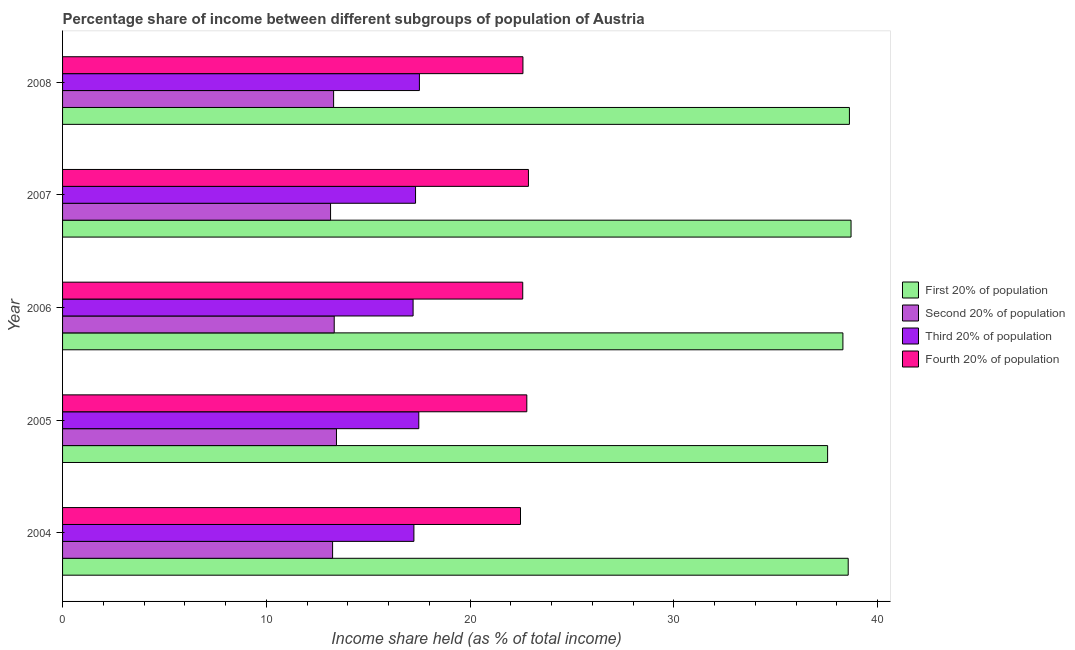How many different coloured bars are there?
Offer a very short reply. 4. How many groups of bars are there?
Make the answer very short. 5. Are the number of bars per tick equal to the number of legend labels?
Ensure brevity in your answer.  Yes. Are the number of bars on each tick of the Y-axis equal?
Provide a succinct answer. Yes. What is the share of the income held by first 20% of the population in 2006?
Provide a succinct answer. 38.29. Across all years, what is the maximum share of the income held by first 20% of the population?
Offer a very short reply. 38.69. Across all years, what is the minimum share of the income held by second 20% of the population?
Provide a succinct answer. 13.15. In which year was the share of the income held by third 20% of the population maximum?
Provide a succinct answer. 2008. What is the total share of the income held by fourth 20% of the population in the graph?
Offer a very short reply. 113.28. What is the difference between the share of the income held by third 20% of the population in 2005 and that in 2008?
Your answer should be compact. -0.03. What is the difference between the share of the income held by first 20% of the population in 2008 and the share of the income held by second 20% of the population in 2007?
Keep it short and to the point. 25.46. What is the average share of the income held by third 20% of the population per year?
Your response must be concise. 17.35. In the year 2006, what is the difference between the share of the income held by fourth 20% of the population and share of the income held by first 20% of the population?
Ensure brevity in your answer.  -15.71. In how many years, is the share of the income held by fourth 20% of the population greater than 28 %?
Ensure brevity in your answer.  0. What is the ratio of the share of the income held by third 20% of the population in 2005 to that in 2006?
Ensure brevity in your answer.  1.02. Is the difference between the share of the income held by fourth 20% of the population in 2005 and 2008 greater than the difference between the share of the income held by third 20% of the population in 2005 and 2008?
Make the answer very short. Yes. What is the difference between the highest and the second highest share of the income held by second 20% of the population?
Offer a terse response. 0.11. What is the difference between the highest and the lowest share of the income held by second 20% of the population?
Provide a short and direct response. 0.29. Is it the case that in every year, the sum of the share of the income held by first 20% of the population and share of the income held by third 20% of the population is greater than the sum of share of the income held by fourth 20% of the population and share of the income held by second 20% of the population?
Offer a very short reply. Yes. What does the 1st bar from the top in 2007 represents?
Provide a succinct answer. Fourth 20% of population. What does the 2nd bar from the bottom in 2008 represents?
Offer a very short reply. Second 20% of population. Is it the case that in every year, the sum of the share of the income held by first 20% of the population and share of the income held by second 20% of the population is greater than the share of the income held by third 20% of the population?
Make the answer very short. Yes. How many years are there in the graph?
Offer a terse response. 5. Are the values on the major ticks of X-axis written in scientific E-notation?
Provide a succinct answer. No. Does the graph contain grids?
Your answer should be very brief. No. Where does the legend appear in the graph?
Give a very brief answer. Center right. What is the title of the graph?
Keep it short and to the point. Percentage share of income between different subgroups of population of Austria. Does "Energy" appear as one of the legend labels in the graph?
Provide a short and direct response. No. What is the label or title of the X-axis?
Offer a very short reply. Income share held (as % of total income). What is the label or title of the Y-axis?
Ensure brevity in your answer.  Year. What is the Income share held (as % of total income) in First 20% of population in 2004?
Your response must be concise. 38.55. What is the Income share held (as % of total income) in Second 20% of population in 2004?
Provide a short and direct response. 13.25. What is the Income share held (as % of total income) of Third 20% of population in 2004?
Your answer should be compact. 17.24. What is the Income share held (as % of total income) in Fourth 20% of population in 2004?
Your answer should be very brief. 22.47. What is the Income share held (as % of total income) in First 20% of population in 2005?
Your answer should be very brief. 37.54. What is the Income share held (as % of total income) in Second 20% of population in 2005?
Your answer should be very brief. 13.44. What is the Income share held (as % of total income) of Third 20% of population in 2005?
Make the answer very short. 17.48. What is the Income share held (as % of total income) in Fourth 20% of population in 2005?
Ensure brevity in your answer.  22.78. What is the Income share held (as % of total income) in First 20% of population in 2006?
Give a very brief answer. 38.29. What is the Income share held (as % of total income) of Second 20% of population in 2006?
Your answer should be compact. 13.33. What is the Income share held (as % of total income) of Fourth 20% of population in 2006?
Make the answer very short. 22.58. What is the Income share held (as % of total income) in First 20% of population in 2007?
Make the answer very short. 38.69. What is the Income share held (as % of total income) of Second 20% of population in 2007?
Give a very brief answer. 13.15. What is the Income share held (as % of total income) in Third 20% of population in 2007?
Offer a very short reply. 17.32. What is the Income share held (as % of total income) in Fourth 20% of population in 2007?
Offer a terse response. 22.86. What is the Income share held (as % of total income) of First 20% of population in 2008?
Your response must be concise. 38.61. What is the Income share held (as % of total income) of Third 20% of population in 2008?
Offer a terse response. 17.51. What is the Income share held (as % of total income) of Fourth 20% of population in 2008?
Offer a very short reply. 22.59. Across all years, what is the maximum Income share held (as % of total income) in First 20% of population?
Your response must be concise. 38.69. Across all years, what is the maximum Income share held (as % of total income) in Second 20% of population?
Offer a terse response. 13.44. Across all years, what is the maximum Income share held (as % of total income) in Third 20% of population?
Your answer should be compact. 17.51. Across all years, what is the maximum Income share held (as % of total income) in Fourth 20% of population?
Keep it short and to the point. 22.86. Across all years, what is the minimum Income share held (as % of total income) of First 20% of population?
Provide a short and direct response. 37.54. Across all years, what is the minimum Income share held (as % of total income) of Second 20% of population?
Provide a short and direct response. 13.15. Across all years, what is the minimum Income share held (as % of total income) of Third 20% of population?
Provide a succinct answer. 17.2. Across all years, what is the minimum Income share held (as % of total income) in Fourth 20% of population?
Give a very brief answer. 22.47. What is the total Income share held (as % of total income) in First 20% of population in the graph?
Your answer should be very brief. 191.68. What is the total Income share held (as % of total income) in Second 20% of population in the graph?
Offer a very short reply. 66.47. What is the total Income share held (as % of total income) of Third 20% of population in the graph?
Make the answer very short. 86.75. What is the total Income share held (as % of total income) of Fourth 20% of population in the graph?
Your answer should be compact. 113.28. What is the difference between the Income share held (as % of total income) of First 20% of population in 2004 and that in 2005?
Your answer should be compact. 1.01. What is the difference between the Income share held (as % of total income) of Second 20% of population in 2004 and that in 2005?
Make the answer very short. -0.19. What is the difference between the Income share held (as % of total income) in Third 20% of population in 2004 and that in 2005?
Provide a succinct answer. -0.24. What is the difference between the Income share held (as % of total income) in Fourth 20% of population in 2004 and that in 2005?
Your answer should be very brief. -0.31. What is the difference between the Income share held (as % of total income) of First 20% of population in 2004 and that in 2006?
Make the answer very short. 0.26. What is the difference between the Income share held (as % of total income) of Second 20% of population in 2004 and that in 2006?
Ensure brevity in your answer.  -0.08. What is the difference between the Income share held (as % of total income) in Fourth 20% of population in 2004 and that in 2006?
Your answer should be compact. -0.11. What is the difference between the Income share held (as % of total income) of First 20% of population in 2004 and that in 2007?
Offer a terse response. -0.14. What is the difference between the Income share held (as % of total income) in Second 20% of population in 2004 and that in 2007?
Keep it short and to the point. 0.1. What is the difference between the Income share held (as % of total income) of Third 20% of population in 2004 and that in 2007?
Offer a terse response. -0.08. What is the difference between the Income share held (as % of total income) of Fourth 20% of population in 2004 and that in 2007?
Offer a very short reply. -0.39. What is the difference between the Income share held (as % of total income) of First 20% of population in 2004 and that in 2008?
Give a very brief answer. -0.06. What is the difference between the Income share held (as % of total income) in Third 20% of population in 2004 and that in 2008?
Provide a short and direct response. -0.27. What is the difference between the Income share held (as % of total income) in Fourth 20% of population in 2004 and that in 2008?
Offer a terse response. -0.12. What is the difference between the Income share held (as % of total income) in First 20% of population in 2005 and that in 2006?
Provide a short and direct response. -0.75. What is the difference between the Income share held (as % of total income) of Second 20% of population in 2005 and that in 2006?
Ensure brevity in your answer.  0.11. What is the difference between the Income share held (as % of total income) of Third 20% of population in 2005 and that in 2006?
Keep it short and to the point. 0.28. What is the difference between the Income share held (as % of total income) of Fourth 20% of population in 2005 and that in 2006?
Ensure brevity in your answer.  0.2. What is the difference between the Income share held (as % of total income) of First 20% of population in 2005 and that in 2007?
Ensure brevity in your answer.  -1.15. What is the difference between the Income share held (as % of total income) of Second 20% of population in 2005 and that in 2007?
Give a very brief answer. 0.29. What is the difference between the Income share held (as % of total income) of Third 20% of population in 2005 and that in 2007?
Keep it short and to the point. 0.16. What is the difference between the Income share held (as % of total income) of Fourth 20% of population in 2005 and that in 2007?
Provide a short and direct response. -0.08. What is the difference between the Income share held (as % of total income) in First 20% of population in 2005 and that in 2008?
Make the answer very short. -1.07. What is the difference between the Income share held (as % of total income) of Second 20% of population in 2005 and that in 2008?
Ensure brevity in your answer.  0.14. What is the difference between the Income share held (as % of total income) in Third 20% of population in 2005 and that in 2008?
Your response must be concise. -0.03. What is the difference between the Income share held (as % of total income) in Fourth 20% of population in 2005 and that in 2008?
Your response must be concise. 0.19. What is the difference between the Income share held (as % of total income) of First 20% of population in 2006 and that in 2007?
Your answer should be very brief. -0.4. What is the difference between the Income share held (as % of total income) of Second 20% of population in 2006 and that in 2007?
Your answer should be compact. 0.18. What is the difference between the Income share held (as % of total income) of Third 20% of population in 2006 and that in 2007?
Offer a very short reply. -0.12. What is the difference between the Income share held (as % of total income) in Fourth 20% of population in 2006 and that in 2007?
Keep it short and to the point. -0.28. What is the difference between the Income share held (as % of total income) in First 20% of population in 2006 and that in 2008?
Offer a very short reply. -0.32. What is the difference between the Income share held (as % of total income) in Third 20% of population in 2006 and that in 2008?
Give a very brief answer. -0.31. What is the difference between the Income share held (as % of total income) in Fourth 20% of population in 2006 and that in 2008?
Your response must be concise. -0.01. What is the difference between the Income share held (as % of total income) in Third 20% of population in 2007 and that in 2008?
Give a very brief answer. -0.19. What is the difference between the Income share held (as % of total income) in Fourth 20% of population in 2007 and that in 2008?
Keep it short and to the point. 0.27. What is the difference between the Income share held (as % of total income) of First 20% of population in 2004 and the Income share held (as % of total income) of Second 20% of population in 2005?
Provide a short and direct response. 25.11. What is the difference between the Income share held (as % of total income) in First 20% of population in 2004 and the Income share held (as % of total income) in Third 20% of population in 2005?
Provide a succinct answer. 21.07. What is the difference between the Income share held (as % of total income) in First 20% of population in 2004 and the Income share held (as % of total income) in Fourth 20% of population in 2005?
Keep it short and to the point. 15.77. What is the difference between the Income share held (as % of total income) in Second 20% of population in 2004 and the Income share held (as % of total income) in Third 20% of population in 2005?
Give a very brief answer. -4.23. What is the difference between the Income share held (as % of total income) in Second 20% of population in 2004 and the Income share held (as % of total income) in Fourth 20% of population in 2005?
Your answer should be compact. -9.53. What is the difference between the Income share held (as % of total income) of Third 20% of population in 2004 and the Income share held (as % of total income) of Fourth 20% of population in 2005?
Make the answer very short. -5.54. What is the difference between the Income share held (as % of total income) in First 20% of population in 2004 and the Income share held (as % of total income) in Second 20% of population in 2006?
Ensure brevity in your answer.  25.22. What is the difference between the Income share held (as % of total income) in First 20% of population in 2004 and the Income share held (as % of total income) in Third 20% of population in 2006?
Your answer should be compact. 21.35. What is the difference between the Income share held (as % of total income) in First 20% of population in 2004 and the Income share held (as % of total income) in Fourth 20% of population in 2006?
Your response must be concise. 15.97. What is the difference between the Income share held (as % of total income) in Second 20% of population in 2004 and the Income share held (as % of total income) in Third 20% of population in 2006?
Provide a short and direct response. -3.95. What is the difference between the Income share held (as % of total income) of Second 20% of population in 2004 and the Income share held (as % of total income) of Fourth 20% of population in 2006?
Offer a very short reply. -9.33. What is the difference between the Income share held (as % of total income) in Third 20% of population in 2004 and the Income share held (as % of total income) in Fourth 20% of population in 2006?
Offer a terse response. -5.34. What is the difference between the Income share held (as % of total income) in First 20% of population in 2004 and the Income share held (as % of total income) in Second 20% of population in 2007?
Your response must be concise. 25.4. What is the difference between the Income share held (as % of total income) of First 20% of population in 2004 and the Income share held (as % of total income) of Third 20% of population in 2007?
Your answer should be compact. 21.23. What is the difference between the Income share held (as % of total income) of First 20% of population in 2004 and the Income share held (as % of total income) of Fourth 20% of population in 2007?
Your answer should be compact. 15.69. What is the difference between the Income share held (as % of total income) in Second 20% of population in 2004 and the Income share held (as % of total income) in Third 20% of population in 2007?
Your answer should be compact. -4.07. What is the difference between the Income share held (as % of total income) of Second 20% of population in 2004 and the Income share held (as % of total income) of Fourth 20% of population in 2007?
Ensure brevity in your answer.  -9.61. What is the difference between the Income share held (as % of total income) in Third 20% of population in 2004 and the Income share held (as % of total income) in Fourth 20% of population in 2007?
Offer a very short reply. -5.62. What is the difference between the Income share held (as % of total income) of First 20% of population in 2004 and the Income share held (as % of total income) of Second 20% of population in 2008?
Ensure brevity in your answer.  25.25. What is the difference between the Income share held (as % of total income) of First 20% of population in 2004 and the Income share held (as % of total income) of Third 20% of population in 2008?
Provide a succinct answer. 21.04. What is the difference between the Income share held (as % of total income) in First 20% of population in 2004 and the Income share held (as % of total income) in Fourth 20% of population in 2008?
Give a very brief answer. 15.96. What is the difference between the Income share held (as % of total income) of Second 20% of population in 2004 and the Income share held (as % of total income) of Third 20% of population in 2008?
Your answer should be very brief. -4.26. What is the difference between the Income share held (as % of total income) in Second 20% of population in 2004 and the Income share held (as % of total income) in Fourth 20% of population in 2008?
Give a very brief answer. -9.34. What is the difference between the Income share held (as % of total income) of Third 20% of population in 2004 and the Income share held (as % of total income) of Fourth 20% of population in 2008?
Offer a very short reply. -5.35. What is the difference between the Income share held (as % of total income) in First 20% of population in 2005 and the Income share held (as % of total income) in Second 20% of population in 2006?
Ensure brevity in your answer.  24.21. What is the difference between the Income share held (as % of total income) of First 20% of population in 2005 and the Income share held (as % of total income) of Third 20% of population in 2006?
Your answer should be very brief. 20.34. What is the difference between the Income share held (as % of total income) in First 20% of population in 2005 and the Income share held (as % of total income) in Fourth 20% of population in 2006?
Provide a short and direct response. 14.96. What is the difference between the Income share held (as % of total income) in Second 20% of population in 2005 and the Income share held (as % of total income) in Third 20% of population in 2006?
Keep it short and to the point. -3.76. What is the difference between the Income share held (as % of total income) in Second 20% of population in 2005 and the Income share held (as % of total income) in Fourth 20% of population in 2006?
Provide a succinct answer. -9.14. What is the difference between the Income share held (as % of total income) of Third 20% of population in 2005 and the Income share held (as % of total income) of Fourth 20% of population in 2006?
Offer a terse response. -5.1. What is the difference between the Income share held (as % of total income) of First 20% of population in 2005 and the Income share held (as % of total income) of Second 20% of population in 2007?
Make the answer very short. 24.39. What is the difference between the Income share held (as % of total income) in First 20% of population in 2005 and the Income share held (as % of total income) in Third 20% of population in 2007?
Your answer should be compact. 20.22. What is the difference between the Income share held (as % of total income) in First 20% of population in 2005 and the Income share held (as % of total income) in Fourth 20% of population in 2007?
Provide a succinct answer. 14.68. What is the difference between the Income share held (as % of total income) in Second 20% of population in 2005 and the Income share held (as % of total income) in Third 20% of population in 2007?
Offer a terse response. -3.88. What is the difference between the Income share held (as % of total income) of Second 20% of population in 2005 and the Income share held (as % of total income) of Fourth 20% of population in 2007?
Give a very brief answer. -9.42. What is the difference between the Income share held (as % of total income) of Third 20% of population in 2005 and the Income share held (as % of total income) of Fourth 20% of population in 2007?
Give a very brief answer. -5.38. What is the difference between the Income share held (as % of total income) of First 20% of population in 2005 and the Income share held (as % of total income) of Second 20% of population in 2008?
Offer a very short reply. 24.24. What is the difference between the Income share held (as % of total income) in First 20% of population in 2005 and the Income share held (as % of total income) in Third 20% of population in 2008?
Give a very brief answer. 20.03. What is the difference between the Income share held (as % of total income) of First 20% of population in 2005 and the Income share held (as % of total income) of Fourth 20% of population in 2008?
Offer a very short reply. 14.95. What is the difference between the Income share held (as % of total income) in Second 20% of population in 2005 and the Income share held (as % of total income) in Third 20% of population in 2008?
Make the answer very short. -4.07. What is the difference between the Income share held (as % of total income) in Second 20% of population in 2005 and the Income share held (as % of total income) in Fourth 20% of population in 2008?
Provide a succinct answer. -9.15. What is the difference between the Income share held (as % of total income) in Third 20% of population in 2005 and the Income share held (as % of total income) in Fourth 20% of population in 2008?
Provide a short and direct response. -5.11. What is the difference between the Income share held (as % of total income) in First 20% of population in 2006 and the Income share held (as % of total income) in Second 20% of population in 2007?
Your answer should be compact. 25.14. What is the difference between the Income share held (as % of total income) of First 20% of population in 2006 and the Income share held (as % of total income) of Third 20% of population in 2007?
Your response must be concise. 20.97. What is the difference between the Income share held (as % of total income) in First 20% of population in 2006 and the Income share held (as % of total income) in Fourth 20% of population in 2007?
Your answer should be compact. 15.43. What is the difference between the Income share held (as % of total income) in Second 20% of population in 2006 and the Income share held (as % of total income) in Third 20% of population in 2007?
Provide a succinct answer. -3.99. What is the difference between the Income share held (as % of total income) in Second 20% of population in 2006 and the Income share held (as % of total income) in Fourth 20% of population in 2007?
Keep it short and to the point. -9.53. What is the difference between the Income share held (as % of total income) in Third 20% of population in 2006 and the Income share held (as % of total income) in Fourth 20% of population in 2007?
Your answer should be very brief. -5.66. What is the difference between the Income share held (as % of total income) of First 20% of population in 2006 and the Income share held (as % of total income) of Second 20% of population in 2008?
Your answer should be compact. 24.99. What is the difference between the Income share held (as % of total income) in First 20% of population in 2006 and the Income share held (as % of total income) in Third 20% of population in 2008?
Your answer should be compact. 20.78. What is the difference between the Income share held (as % of total income) in First 20% of population in 2006 and the Income share held (as % of total income) in Fourth 20% of population in 2008?
Make the answer very short. 15.7. What is the difference between the Income share held (as % of total income) of Second 20% of population in 2006 and the Income share held (as % of total income) of Third 20% of population in 2008?
Your answer should be very brief. -4.18. What is the difference between the Income share held (as % of total income) in Second 20% of population in 2006 and the Income share held (as % of total income) in Fourth 20% of population in 2008?
Your answer should be very brief. -9.26. What is the difference between the Income share held (as % of total income) in Third 20% of population in 2006 and the Income share held (as % of total income) in Fourth 20% of population in 2008?
Keep it short and to the point. -5.39. What is the difference between the Income share held (as % of total income) in First 20% of population in 2007 and the Income share held (as % of total income) in Second 20% of population in 2008?
Offer a terse response. 25.39. What is the difference between the Income share held (as % of total income) in First 20% of population in 2007 and the Income share held (as % of total income) in Third 20% of population in 2008?
Provide a succinct answer. 21.18. What is the difference between the Income share held (as % of total income) in First 20% of population in 2007 and the Income share held (as % of total income) in Fourth 20% of population in 2008?
Give a very brief answer. 16.1. What is the difference between the Income share held (as % of total income) in Second 20% of population in 2007 and the Income share held (as % of total income) in Third 20% of population in 2008?
Your response must be concise. -4.36. What is the difference between the Income share held (as % of total income) of Second 20% of population in 2007 and the Income share held (as % of total income) of Fourth 20% of population in 2008?
Provide a succinct answer. -9.44. What is the difference between the Income share held (as % of total income) in Third 20% of population in 2007 and the Income share held (as % of total income) in Fourth 20% of population in 2008?
Your answer should be very brief. -5.27. What is the average Income share held (as % of total income) of First 20% of population per year?
Ensure brevity in your answer.  38.34. What is the average Income share held (as % of total income) in Second 20% of population per year?
Offer a terse response. 13.29. What is the average Income share held (as % of total income) in Third 20% of population per year?
Offer a terse response. 17.35. What is the average Income share held (as % of total income) of Fourth 20% of population per year?
Your response must be concise. 22.66. In the year 2004, what is the difference between the Income share held (as % of total income) of First 20% of population and Income share held (as % of total income) of Second 20% of population?
Keep it short and to the point. 25.3. In the year 2004, what is the difference between the Income share held (as % of total income) of First 20% of population and Income share held (as % of total income) of Third 20% of population?
Your response must be concise. 21.31. In the year 2004, what is the difference between the Income share held (as % of total income) in First 20% of population and Income share held (as % of total income) in Fourth 20% of population?
Provide a succinct answer. 16.08. In the year 2004, what is the difference between the Income share held (as % of total income) of Second 20% of population and Income share held (as % of total income) of Third 20% of population?
Provide a succinct answer. -3.99. In the year 2004, what is the difference between the Income share held (as % of total income) of Second 20% of population and Income share held (as % of total income) of Fourth 20% of population?
Offer a terse response. -9.22. In the year 2004, what is the difference between the Income share held (as % of total income) of Third 20% of population and Income share held (as % of total income) of Fourth 20% of population?
Provide a short and direct response. -5.23. In the year 2005, what is the difference between the Income share held (as % of total income) of First 20% of population and Income share held (as % of total income) of Second 20% of population?
Provide a short and direct response. 24.1. In the year 2005, what is the difference between the Income share held (as % of total income) in First 20% of population and Income share held (as % of total income) in Third 20% of population?
Ensure brevity in your answer.  20.06. In the year 2005, what is the difference between the Income share held (as % of total income) of First 20% of population and Income share held (as % of total income) of Fourth 20% of population?
Provide a short and direct response. 14.76. In the year 2005, what is the difference between the Income share held (as % of total income) in Second 20% of population and Income share held (as % of total income) in Third 20% of population?
Provide a succinct answer. -4.04. In the year 2005, what is the difference between the Income share held (as % of total income) in Second 20% of population and Income share held (as % of total income) in Fourth 20% of population?
Your answer should be very brief. -9.34. In the year 2005, what is the difference between the Income share held (as % of total income) in Third 20% of population and Income share held (as % of total income) in Fourth 20% of population?
Provide a succinct answer. -5.3. In the year 2006, what is the difference between the Income share held (as % of total income) of First 20% of population and Income share held (as % of total income) of Second 20% of population?
Keep it short and to the point. 24.96. In the year 2006, what is the difference between the Income share held (as % of total income) in First 20% of population and Income share held (as % of total income) in Third 20% of population?
Offer a terse response. 21.09. In the year 2006, what is the difference between the Income share held (as % of total income) in First 20% of population and Income share held (as % of total income) in Fourth 20% of population?
Provide a succinct answer. 15.71. In the year 2006, what is the difference between the Income share held (as % of total income) in Second 20% of population and Income share held (as % of total income) in Third 20% of population?
Provide a succinct answer. -3.87. In the year 2006, what is the difference between the Income share held (as % of total income) in Second 20% of population and Income share held (as % of total income) in Fourth 20% of population?
Keep it short and to the point. -9.25. In the year 2006, what is the difference between the Income share held (as % of total income) of Third 20% of population and Income share held (as % of total income) of Fourth 20% of population?
Provide a succinct answer. -5.38. In the year 2007, what is the difference between the Income share held (as % of total income) of First 20% of population and Income share held (as % of total income) of Second 20% of population?
Provide a short and direct response. 25.54. In the year 2007, what is the difference between the Income share held (as % of total income) of First 20% of population and Income share held (as % of total income) of Third 20% of population?
Offer a very short reply. 21.37. In the year 2007, what is the difference between the Income share held (as % of total income) of First 20% of population and Income share held (as % of total income) of Fourth 20% of population?
Your response must be concise. 15.83. In the year 2007, what is the difference between the Income share held (as % of total income) of Second 20% of population and Income share held (as % of total income) of Third 20% of population?
Your response must be concise. -4.17. In the year 2007, what is the difference between the Income share held (as % of total income) in Second 20% of population and Income share held (as % of total income) in Fourth 20% of population?
Give a very brief answer. -9.71. In the year 2007, what is the difference between the Income share held (as % of total income) of Third 20% of population and Income share held (as % of total income) of Fourth 20% of population?
Offer a terse response. -5.54. In the year 2008, what is the difference between the Income share held (as % of total income) in First 20% of population and Income share held (as % of total income) in Second 20% of population?
Your response must be concise. 25.31. In the year 2008, what is the difference between the Income share held (as % of total income) of First 20% of population and Income share held (as % of total income) of Third 20% of population?
Offer a very short reply. 21.1. In the year 2008, what is the difference between the Income share held (as % of total income) in First 20% of population and Income share held (as % of total income) in Fourth 20% of population?
Your answer should be compact. 16.02. In the year 2008, what is the difference between the Income share held (as % of total income) of Second 20% of population and Income share held (as % of total income) of Third 20% of population?
Offer a very short reply. -4.21. In the year 2008, what is the difference between the Income share held (as % of total income) in Second 20% of population and Income share held (as % of total income) in Fourth 20% of population?
Your answer should be very brief. -9.29. In the year 2008, what is the difference between the Income share held (as % of total income) of Third 20% of population and Income share held (as % of total income) of Fourth 20% of population?
Your answer should be very brief. -5.08. What is the ratio of the Income share held (as % of total income) in First 20% of population in 2004 to that in 2005?
Provide a succinct answer. 1.03. What is the ratio of the Income share held (as % of total income) in Second 20% of population in 2004 to that in 2005?
Offer a terse response. 0.99. What is the ratio of the Income share held (as % of total income) of Third 20% of population in 2004 to that in 2005?
Offer a very short reply. 0.99. What is the ratio of the Income share held (as % of total income) in Fourth 20% of population in 2004 to that in 2005?
Your answer should be very brief. 0.99. What is the ratio of the Income share held (as % of total income) of First 20% of population in 2004 to that in 2006?
Provide a short and direct response. 1.01. What is the ratio of the Income share held (as % of total income) in Second 20% of population in 2004 to that in 2006?
Ensure brevity in your answer.  0.99. What is the ratio of the Income share held (as % of total income) of Third 20% of population in 2004 to that in 2006?
Offer a terse response. 1. What is the ratio of the Income share held (as % of total income) of Fourth 20% of population in 2004 to that in 2006?
Keep it short and to the point. 1. What is the ratio of the Income share held (as % of total income) of First 20% of population in 2004 to that in 2007?
Your answer should be compact. 1. What is the ratio of the Income share held (as % of total income) in Second 20% of population in 2004 to that in 2007?
Keep it short and to the point. 1.01. What is the ratio of the Income share held (as % of total income) of Fourth 20% of population in 2004 to that in 2007?
Offer a very short reply. 0.98. What is the ratio of the Income share held (as % of total income) of Third 20% of population in 2004 to that in 2008?
Ensure brevity in your answer.  0.98. What is the ratio of the Income share held (as % of total income) of Fourth 20% of population in 2004 to that in 2008?
Your response must be concise. 0.99. What is the ratio of the Income share held (as % of total income) of First 20% of population in 2005 to that in 2006?
Ensure brevity in your answer.  0.98. What is the ratio of the Income share held (as % of total income) in Second 20% of population in 2005 to that in 2006?
Keep it short and to the point. 1.01. What is the ratio of the Income share held (as % of total income) of Third 20% of population in 2005 to that in 2006?
Your response must be concise. 1.02. What is the ratio of the Income share held (as % of total income) in Fourth 20% of population in 2005 to that in 2006?
Keep it short and to the point. 1.01. What is the ratio of the Income share held (as % of total income) in First 20% of population in 2005 to that in 2007?
Give a very brief answer. 0.97. What is the ratio of the Income share held (as % of total income) in Second 20% of population in 2005 to that in 2007?
Provide a succinct answer. 1.02. What is the ratio of the Income share held (as % of total income) in Third 20% of population in 2005 to that in 2007?
Your response must be concise. 1.01. What is the ratio of the Income share held (as % of total income) of First 20% of population in 2005 to that in 2008?
Provide a succinct answer. 0.97. What is the ratio of the Income share held (as % of total income) in Second 20% of population in 2005 to that in 2008?
Your answer should be compact. 1.01. What is the ratio of the Income share held (as % of total income) of Fourth 20% of population in 2005 to that in 2008?
Your answer should be compact. 1.01. What is the ratio of the Income share held (as % of total income) of Second 20% of population in 2006 to that in 2007?
Your response must be concise. 1.01. What is the ratio of the Income share held (as % of total income) of First 20% of population in 2006 to that in 2008?
Your response must be concise. 0.99. What is the ratio of the Income share held (as % of total income) in Second 20% of population in 2006 to that in 2008?
Provide a succinct answer. 1. What is the ratio of the Income share held (as % of total income) of Third 20% of population in 2006 to that in 2008?
Give a very brief answer. 0.98. What is the ratio of the Income share held (as % of total income) in Second 20% of population in 2007 to that in 2008?
Make the answer very short. 0.99. What is the ratio of the Income share held (as % of total income) of Third 20% of population in 2007 to that in 2008?
Provide a succinct answer. 0.99. What is the difference between the highest and the second highest Income share held (as % of total income) of Second 20% of population?
Give a very brief answer. 0.11. What is the difference between the highest and the lowest Income share held (as % of total income) of First 20% of population?
Your answer should be compact. 1.15. What is the difference between the highest and the lowest Income share held (as % of total income) in Second 20% of population?
Provide a short and direct response. 0.29. What is the difference between the highest and the lowest Income share held (as % of total income) of Third 20% of population?
Make the answer very short. 0.31. What is the difference between the highest and the lowest Income share held (as % of total income) of Fourth 20% of population?
Keep it short and to the point. 0.39. 